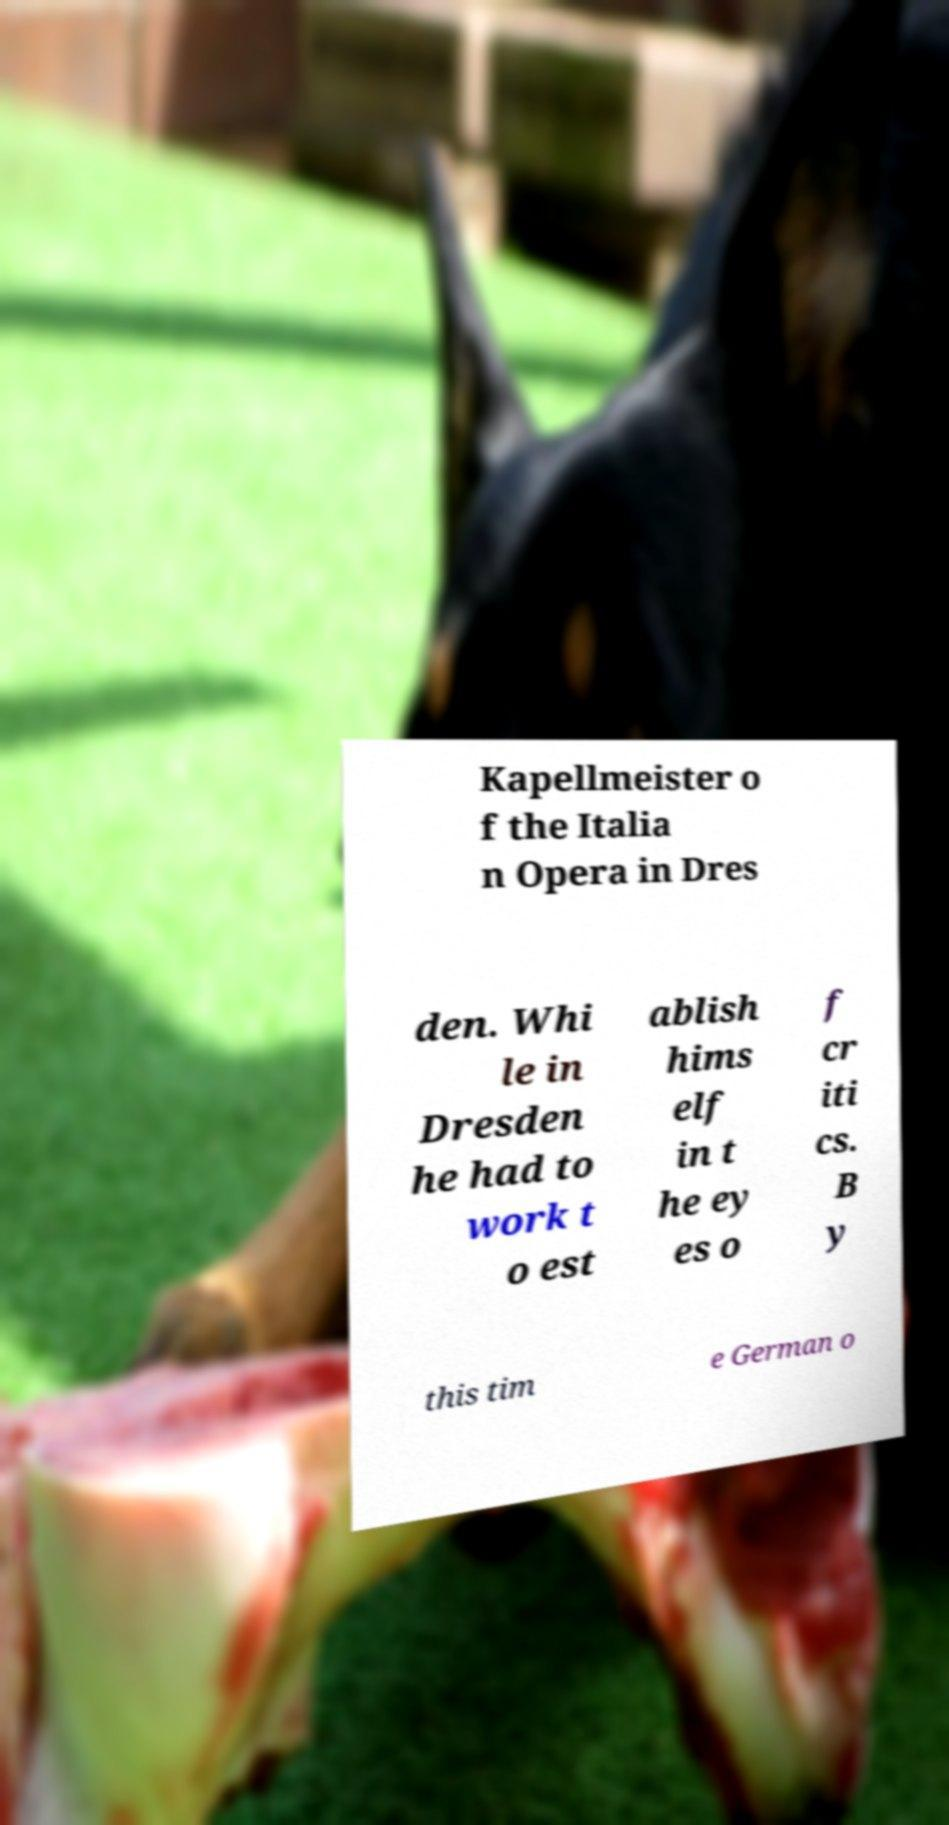I need the written content from this picture converted into text. Can you do that? Kapellmeister o f the Italia n Opera in Dres den. Whi le in Dresden he had to work t o est ablish hims elf in t he ey es o f cr iti cs. B y this tim e German o 